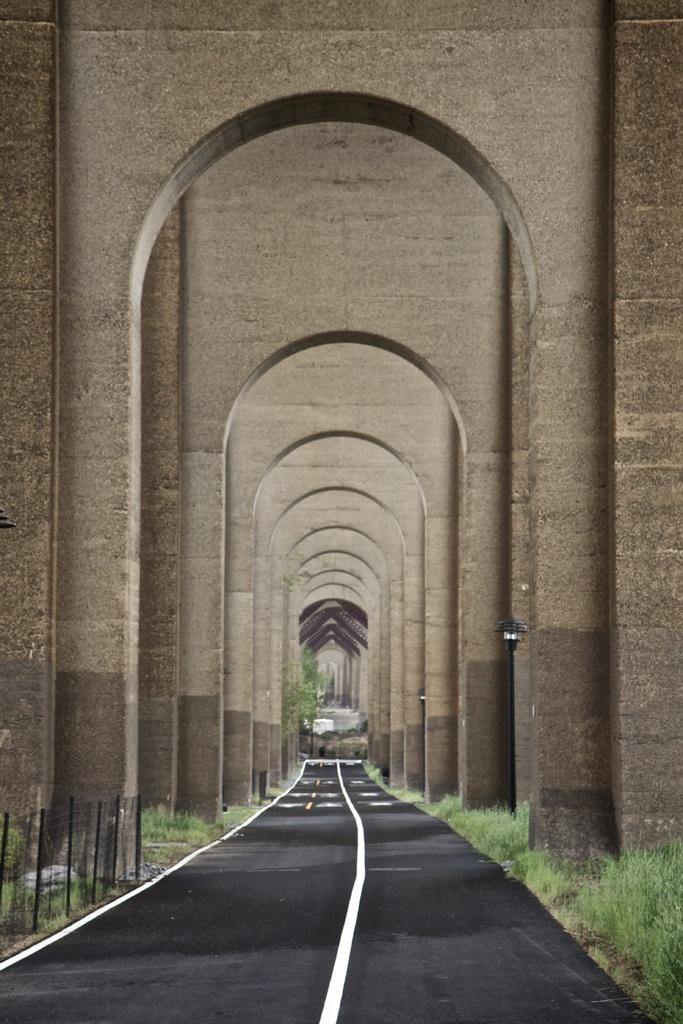What structure is present in the image? There is a gateway in the image. What is located beneath the gateway? There is a road under the gateway. What type of vegetation is visible beside the road? Grass is visible beside the road. What can be seen in the background of the image? There is a building in the background of the image. What type of roof can be seen on the table in the image? There is no table or roof present in the image. What kind of apparatus is used to maintain the gateway in the image? There is no apparatus mentioned or visible in the image related to maintaining the gateway. 